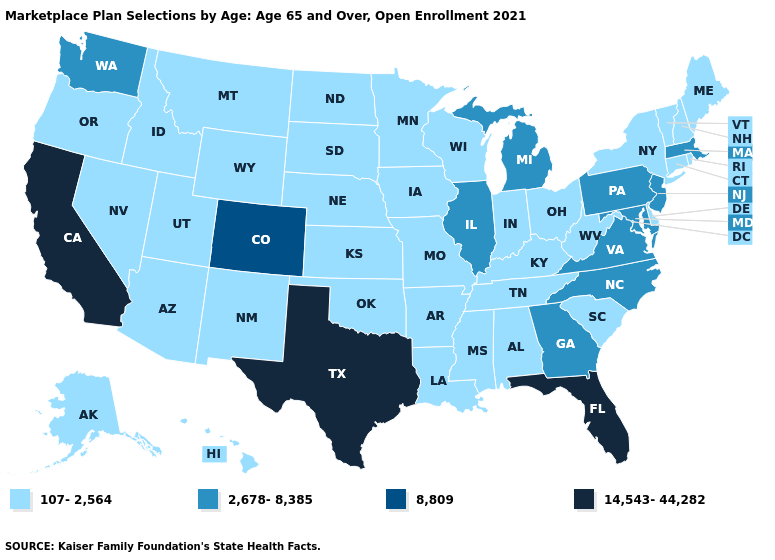Which states have the highest value in the USA?
Keep it brief. California, Florida, Texas. Which states hav the highest value in the MidWest?
Short answer required. Illinois, Michigan. What is the value of Texas?
Give a very brief answer. 14,543-44,282. Which states hav the highest value in the South?
Be succinct. Florida, Texas. Does Virginia have the highest value in the South?
Give a very brief answer. No. What is the value of Tennessee?
Answer briefly. 107-2,564. Among the states that border South Carolina , which have the lowest value?
Write a very short answer. Georgia, North Carolina. What is the lowest value in the Northeast?
Keep it brief. 107-2,564. Name the states that have a value in the range 107-2,564?
Answer briefly. Alabama, Alaska, Arizona, Arkansas, Connecticut, Delaware, Hawaii, Idaho, Indiana, Iowa, Kansas, Kentucky, Louisiana, Maine, Minnesota, Mississippi, Missouri, Montana, Nebraska, Nevada, New Hampshire, New Mexico, New York, North Dakota, Ohio, Oklahoma, Oregon, Rhode Island, South Carolina, South Dakota, Tennessee, Utah, Vermont, West Virginia, Wisconsin, Wyoming. Does the first symbol in the legend represent the smallest category?
Concise answer only. Yes. What is the value of Virginia?
Short answer required. 2,678-8,385. Which states hav the highest value in the South?
Quick response, please. Florida, Texas. What is the value of New Hampshire?
Concise answer only. 107-2,564. Among the states that border New Jersey , which have the highest value?
Quick response, please. Pennsylvania. 